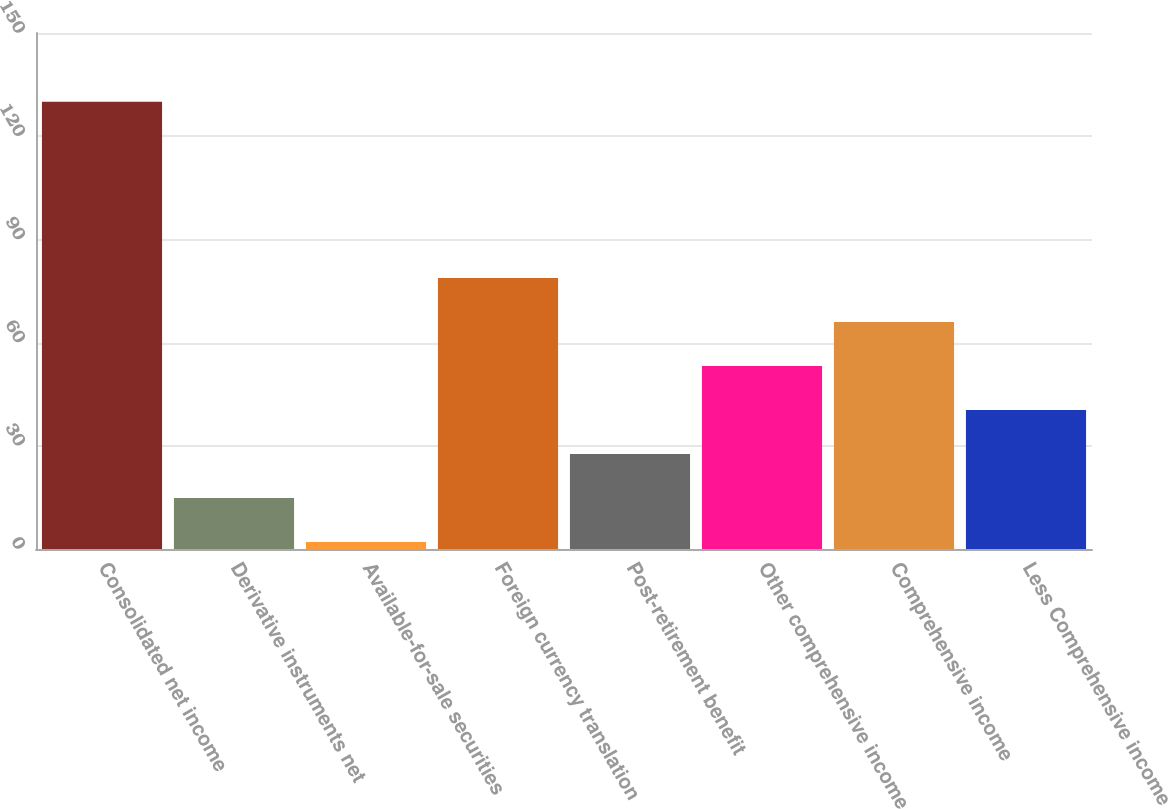<chart> <loc_0><loc_0><loc_500><loc_500><bar_chart><fcel>Consolidated net income<fcel>Derivative instruments net<fcel>Available-for-sale securities<fcel>Foreign currency translation<fcel>Post-retirement benefit<fcel>Other comprehensive income<fcel>Comprehensive income<fcel>Less Comprehensive income<nl><fcel>130<fcel>14.8<fcel>2<fcel>78.8<fcel>27.6<fcel>53.2<fcel>66<fcel>40.4<nl></chart> 